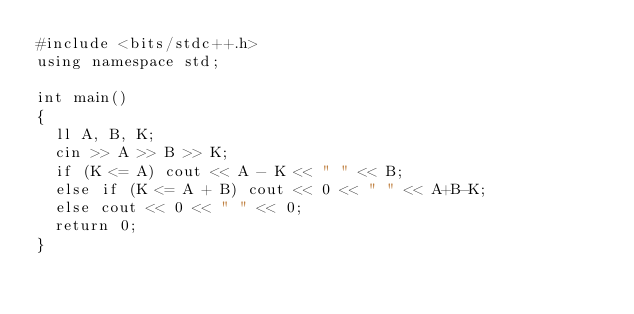Convert code to text. <code><loc_0><loc_0><loc_500><loc_500><_C++_>#include <bits/stdc++.h>
using namespace std;

int main() 
{
	ll A, B, K;
	cin >> A >> B >> K;
	if (K <= A) cout << A - K << " " << B;
	else if (K <= A + B) cout << 0 << " " << A+B-K;
	else cout << 0 << " " << 0;
	return 0;
}</code> 